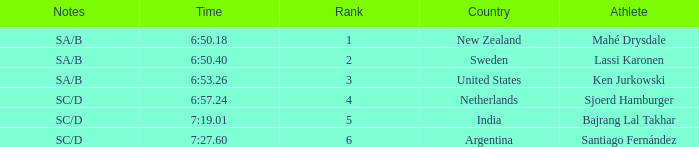What is listed in notes for the athlete, lassi karonen? SA/B. 